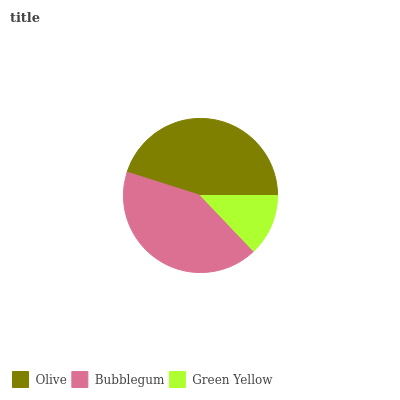Is Green Yellow the minimum?
Answer yes or no. Yes. Is Olive the maximum?
Answer yes or no. Yes. Is Bubblegum the minimum?
Answer yes or no. No. Is Bubblegum the maximum?
Answer yes or no. No. Is Olive greater than Bubblegum?
Answer yes or no. Yes. Is Bubblegum less than Olive?
Answer yes or no. Yes. Is Bubblegum greater than Olive?
Answer yes or no. No. Is Olive less than Bubblegum?
Answer yes or no. No. Is Bubblegum the high median?
Answer yes or no. Yes. Is Bubblegum the low median?
Answer yes or no. Yes. Is Green Yellow the high median?
Answer yes or no. No. Is Olive the low median?
Answer yes or no. No. 